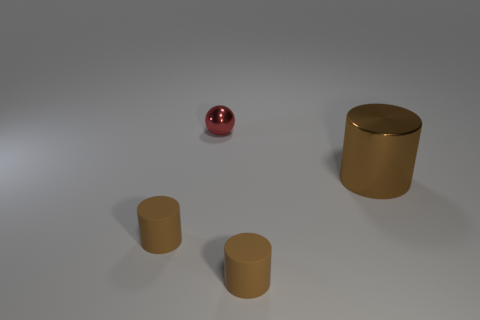How many brown cylinders must be subtracted to get 1 brown cylinders? 2 Subtract all balls. How many objects are left? 3 Add 2 big brown metallic things. How many objects exist? 6 Subtract all small cylinders. How many cylinders are left? 1 Subtract 0 green balls. How many objects are left? 4 Subtract 1 cylinders. How many cylinders are left? 2 Subtract all brown balls. Subtract all purple cylinders. How many balls are left? 1 Subtract all green spheres. How many cyan cylinders are left? 0 Subtract all brown rubber cylinders. Subtract all big objects. How many objects are left? 1 Add 3 big brown cylinders. How many big brown cylinders are left? 4 